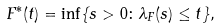<formula> <loc_0><loc_0><loc_500><loc_500>F ^ { \ast } ( t ) = \inf \{ s > 0 \colon \lambda _ { F } ( s ) \leq t \} ,</formula> 